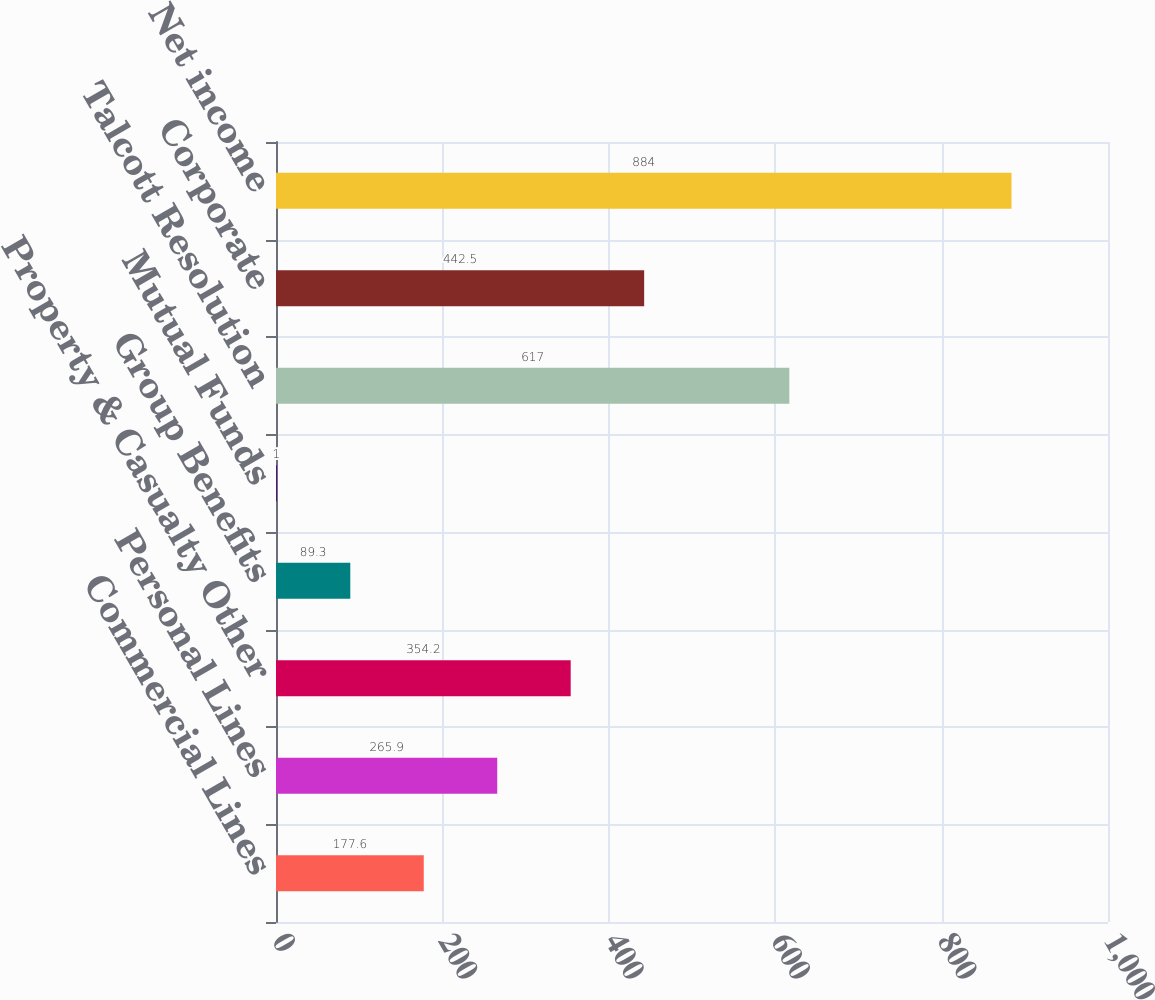Convert chart. <chart><loc_0><loc_0><loc_500><loc_500><bar_chart><fcel>Commercial Lines<fcel>Personal Lines<fcel>Property & Casualty Other<fcel>Group Benefits<fcel>Mutual Funds<fcel>Talcott Resolution<fcel>Corporate<fcel>Net income<nl><fcel>177.6<fcel>265.9<fcel>354.2<fcel>89.3<fcel>1<fcel>617<fcel>442.5<fcel>884<nl></chart> 